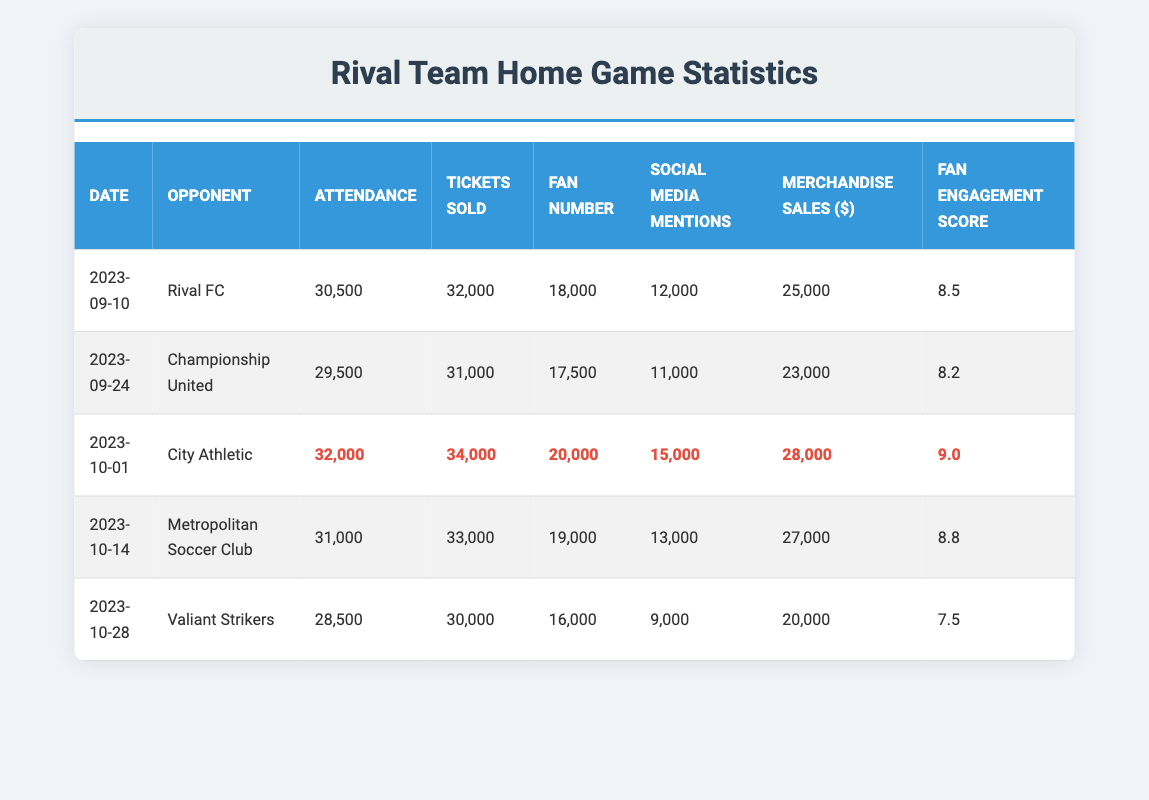What was the highest attendance recorded during the home games? The highest attendance figure is found in the row for the game against City Athletic on October 1, which shows an attendance of 32,000.
Answer: 32,000 How many tickets were sold in the game against Championship United? The table lists the number of tickets sold for Championship United, which is 31,000.
Answer: 31,000 Which game had the highest fan engagement score? By reviewing the fan engagement scores, the game against City Athletic on October 1 has the highest score of 9.0.
Answer: 9.0 What is the average attendance of all home games? To find the average, we sum all the attendance figures: 30,500 + 29,500 + 32,000 + 31,000 + 28,500 = 151,500. Then divide by the number of games (5): 151,500 / 5 = 30,300.
Answer: 30,300 Did the game against Valiant Strikers have more or fewer than 30,000 attendees? The attendance for the Valiant Strikers game is 28,500, which is fewer than 30,000.
Answer: Fewer What was the total merchandise sales from the home games? Adding up the merchandise sales gives: 25,000 + 23,000 + 28,000 + 27,000 + 20,000 = 123,000 in total merchandise sales for all home games.
Answer: 123,000 In which game did the number of social media mentions exceed 14,000? Only the game against City Athletic had social media mentions greater than 14,000, with 15,000 mentions. All other games had lower numbers.
Answer: City Athletic game How much was the difference in attendance between the game against City Athletic and the game against Valiant Strikers? The attendance for City Athletic was 32,000 and for Valiant Strikers was 28,500. Calculating the difference: 32,000 - 28,500 = 3,500.
Answer: 3,500 What was the total fan number across all home games? Summing the fan numbers: 18,000 + 17,500 + 20,000 + 19,000 + 16,000 = 90,500 gives the total fan number across all home games.
Answer: 90,500 Which opponent had the lowest fan engagement score? The game against Valiant Strikers had the lowest fan engagement score of 7.5, the lowest score in the table.
Answer: Valiant Strikers 